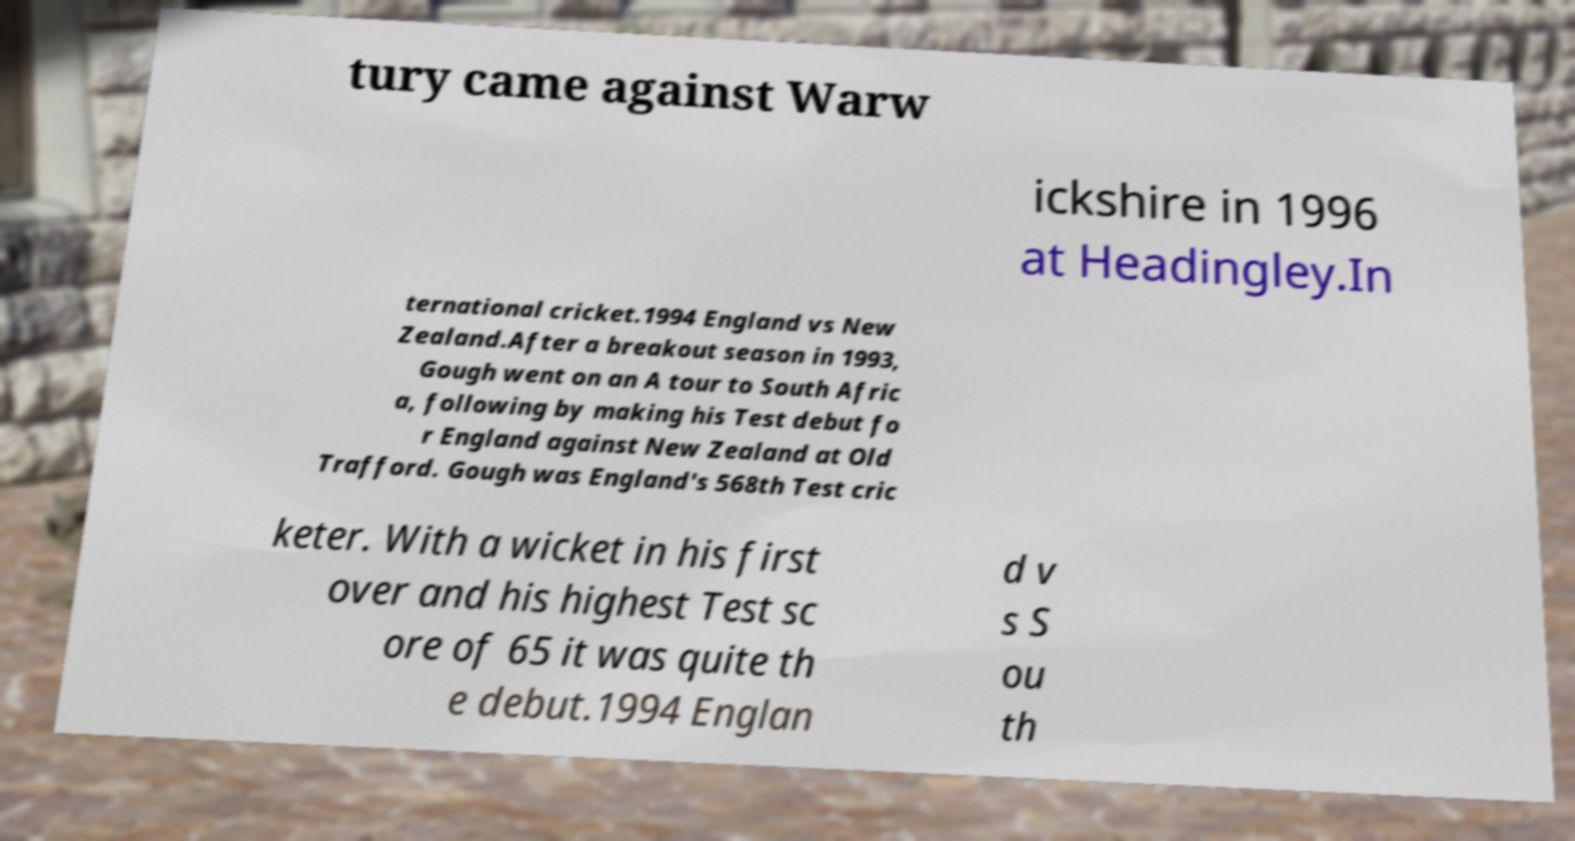Could you extract and type out the text from this image? tury came against Warw ickshire in 1996 at Headingley.In ternational cricket.1994 England vs New Zealand.After a breakout season in 1993, Gough went on an A tour to South Afric a, following by making his Test debut fo r England against New Zealand at Old Trafford. Gough was England's 568th Test cric keter. With a wicket in his first over and his highest Test sc ore of 65 it was quite th e debut.1994 Englan d v s S ou th 